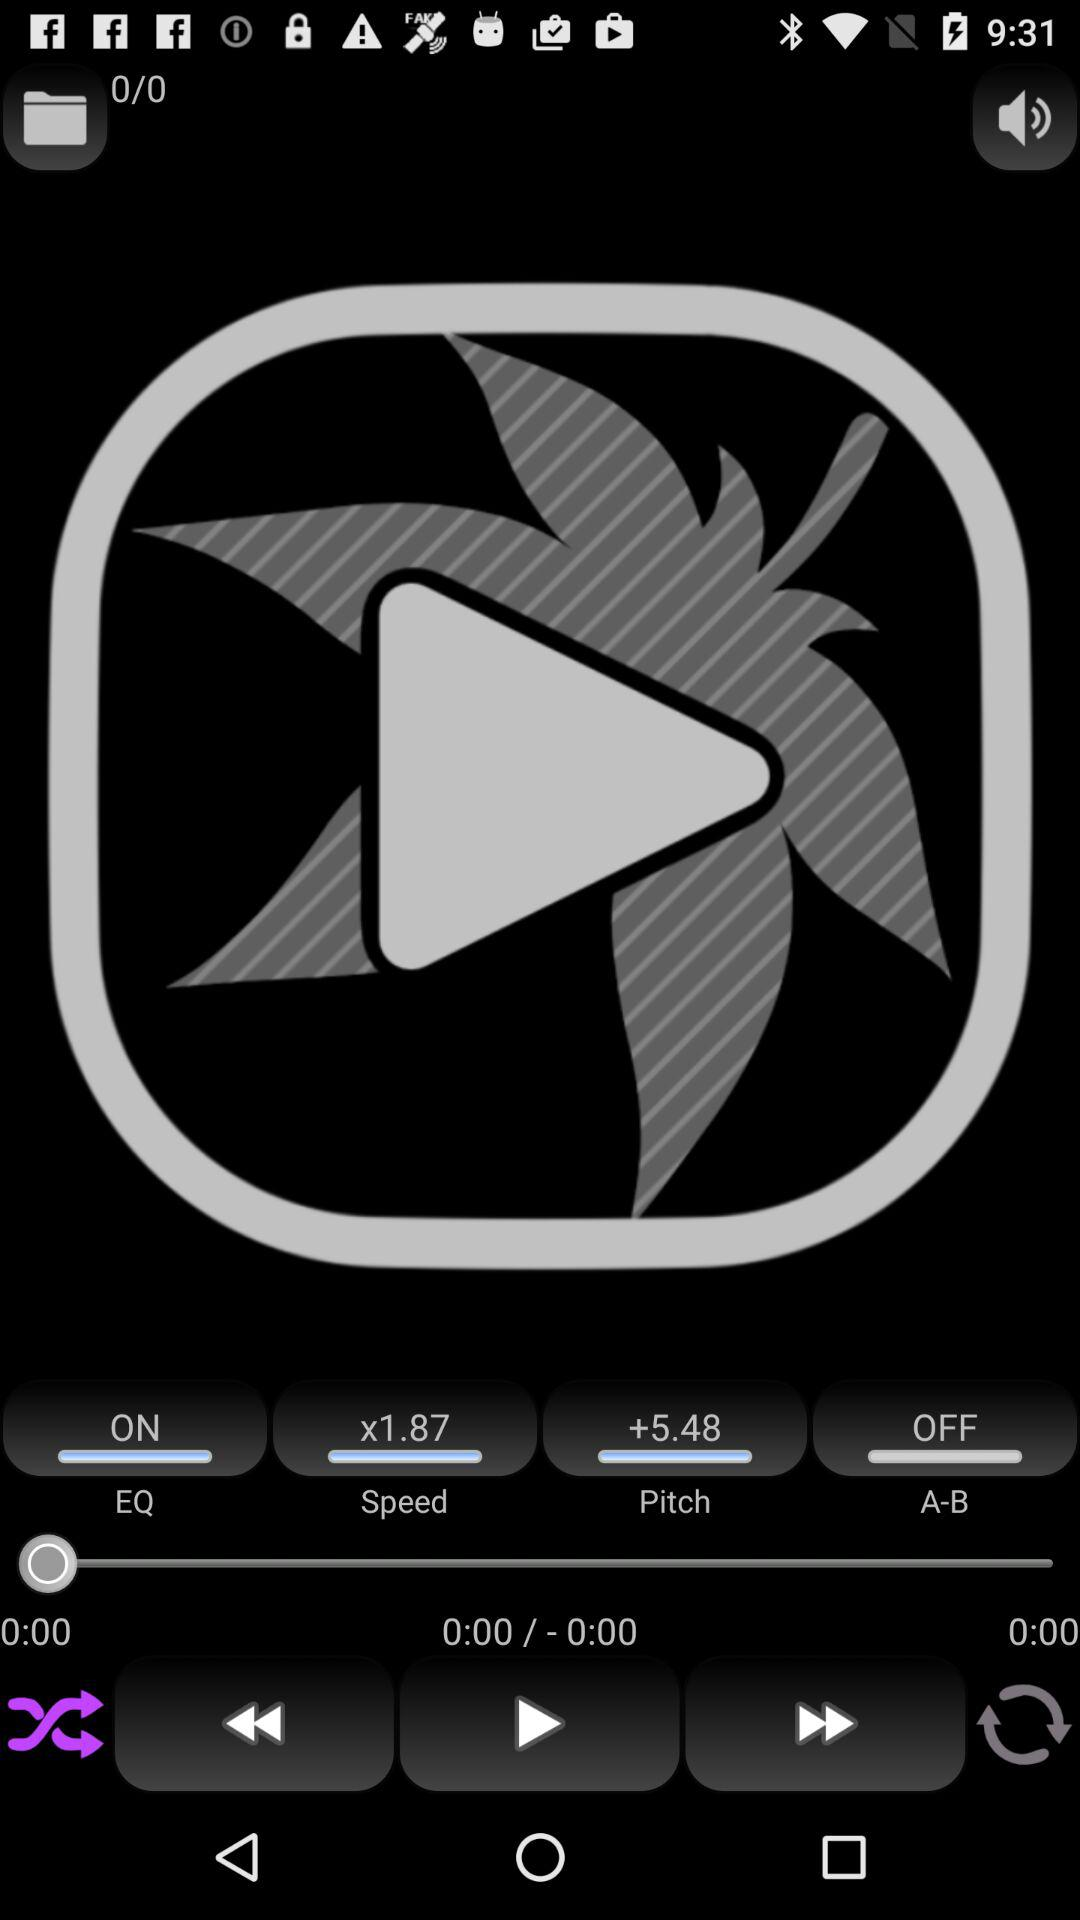What is the current status of the "A-B"? "A-B" is turned off. 